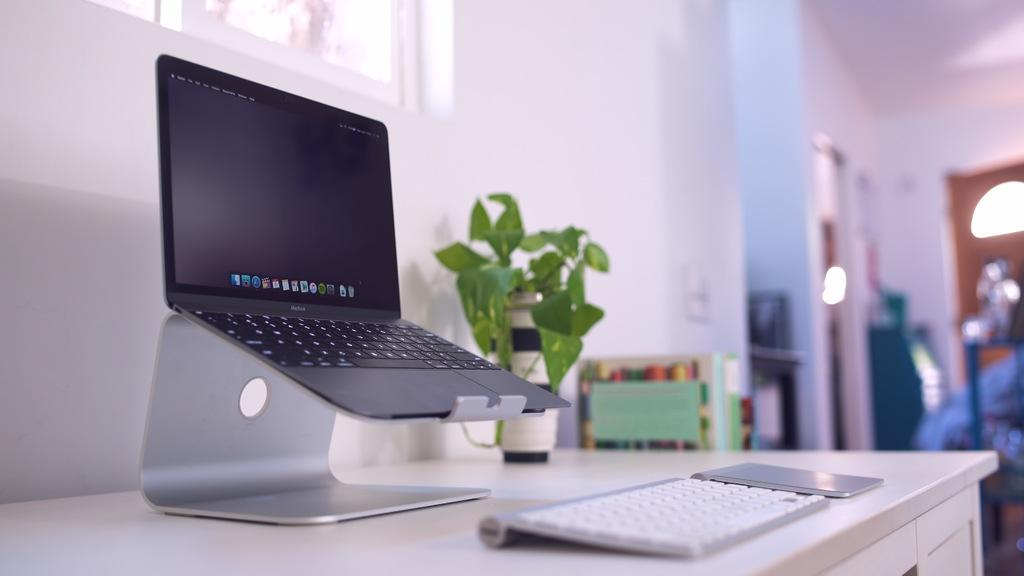What piece of furniture is present in the image? There is a table in the image. What electronic device is on the table? There is a laptop on the table. What other object is on the table? There is a keyboard and a plant on the table. Can you describe the background of the image? The background of the image is blurred. What type of authority figure can be seen in the image? There is no authority figure present in the image. Is there a stove visible in the image? There is no stove present in the image. Did an earthquake occur during the time the image was taken? There is no information about an earthquake in the image or the provided facts. 